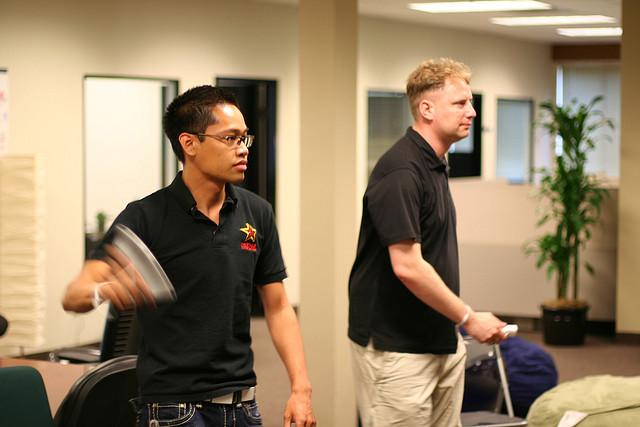What activity are the men involved in? wii 